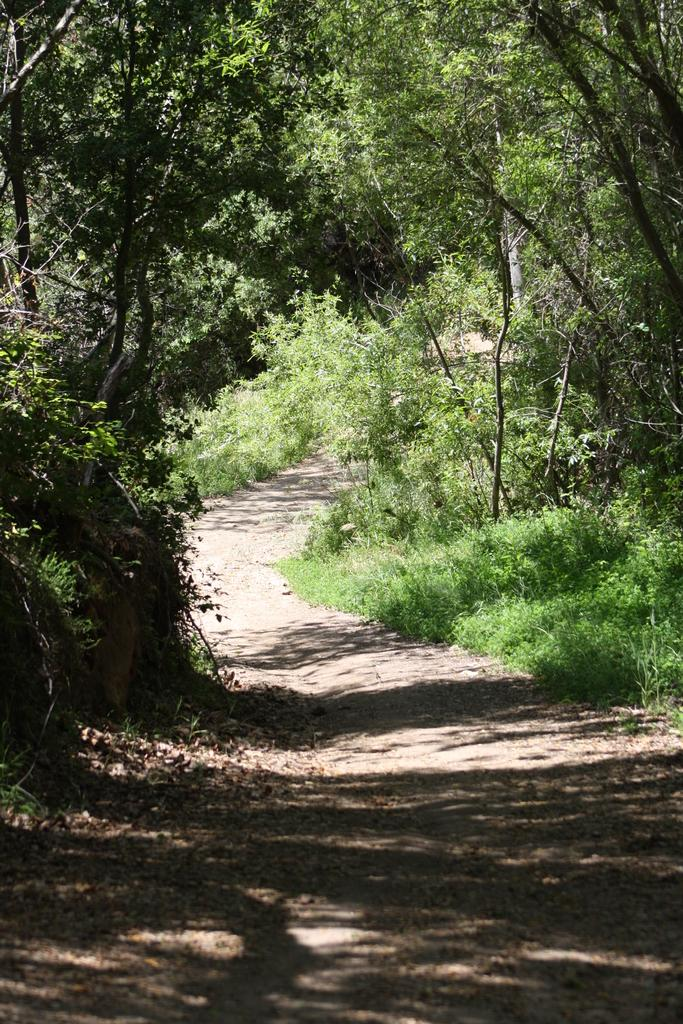What is the main feature of the image? There is a path in the image. What type of natural elements can be seen in the image? There are trees in the image. What type of disease is affecting the trees in the image? There is no indication of any disease affecting the trees in the image; they appear healthy. What type of creature can be seen walking along the path in the image? There is no creature visible in the image; only the path and trees are present. 